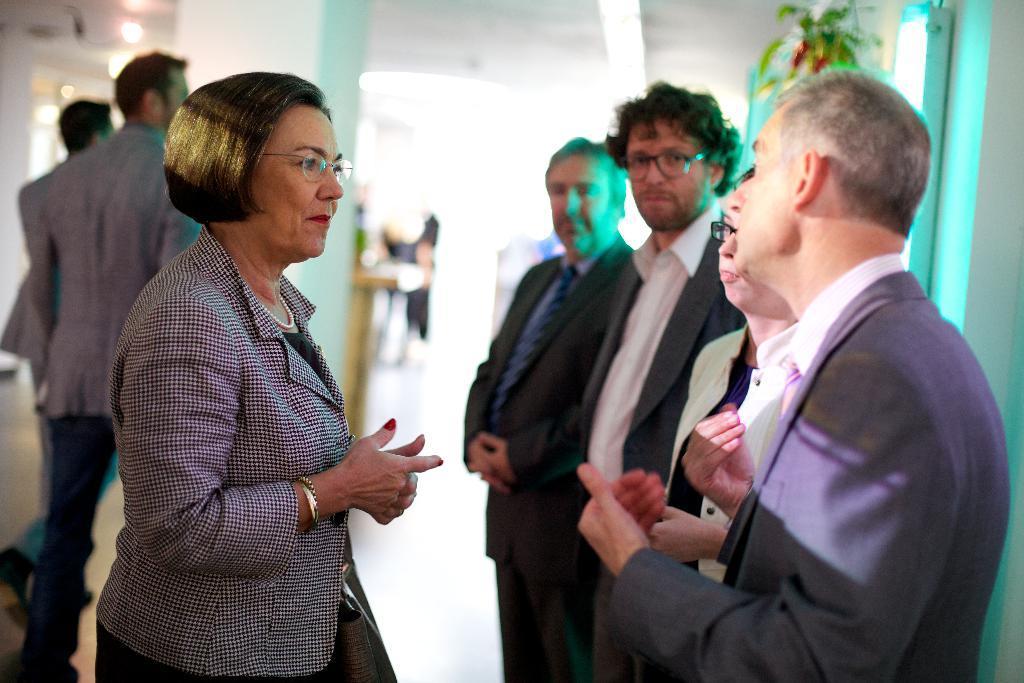Could you give a brief overview of what you see in this image? In this image there are a few people standing and walking on the floor. On the right side of the image there is a plant hanging on the wall. In the background there is a pillar, behind the pillar there is a table, there are a few people standing and a wall. 